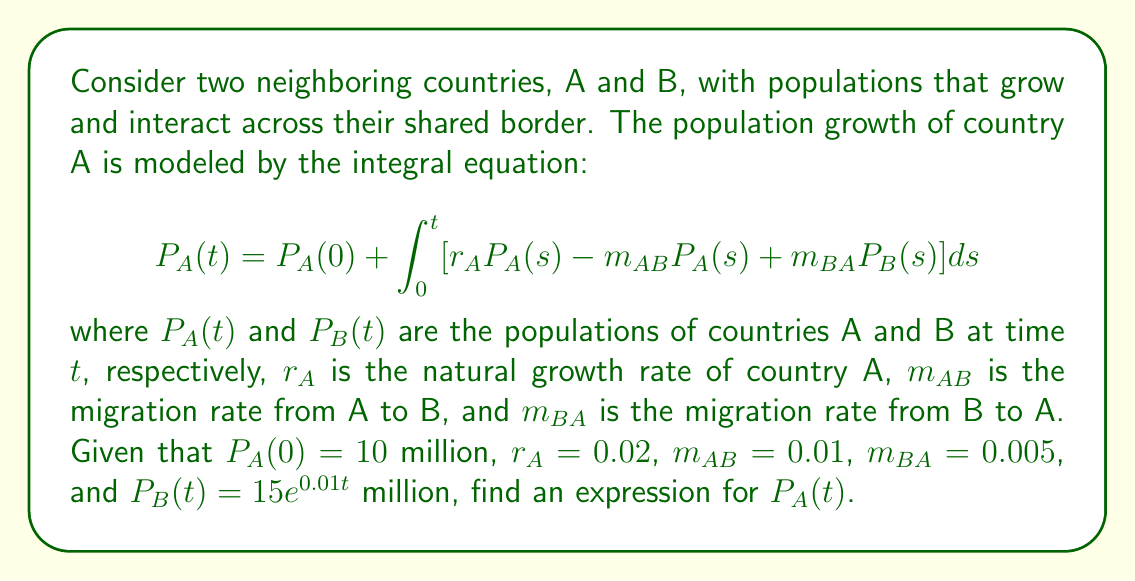Provide a solution to this math problem. To solve this integral equation, we'll follow these steps:

1) First, we substitute the given values and function for $P_B(t)$ into the equation:

   $$P_A(t) = 10 + \int_0^t [0.02P_A(s) - 0.01P_A(s) + 0.005(15e^{0.01s})] ds$$

2) Simplify the integrand:

   $$P_A(t) = 10 + \int_0^t [0.01P_A(s) + 0.075e^{0.01s}] ds$$

3) To solve this, we can use the method of differentiating both sides with respect to $t$:

   $$\frac{d}{dt}P_A(t) = 0.01P_A(t) + 0.075e^{0.01t}$$

4) This is a first-order linear differential equation. We can solve it using an integrating factor:

   Integrating factor: $e^{-0.01t}$

   Multiply both sides by the integrating factor:

   $$e^{-0.01t}\frac{d}{dt}P_A(t) - 0.01e^{-0.01t}P_A(t) = 0.075$$

5) The left side is now the derivative of $e^{-0.01t}P_A(t)$:

   $$\frac{d}{dt}[e^{-0.01t}P_A(t)] = 0.075$$

6) Integrate both sides:

   $$e^{-0.01t}P_A(t) = 0.075t + C$$

7) Solve for $P_A(t)$:

   $$P_A(t) = 0.075te^{0.01t} + Ce^{0.01t}$$

8) Use the initial condition $P_A(0) = 10$ to find $C$:

   $$10 = C$$

9) Therefore, the final solution is:

   $$P_A(t) = 0.075te^{0.01t} + 10e^{0.01t}$$
Answer: $P_A(t) = 0.075te^{0.01t} + 10e^{0.01t}$ 